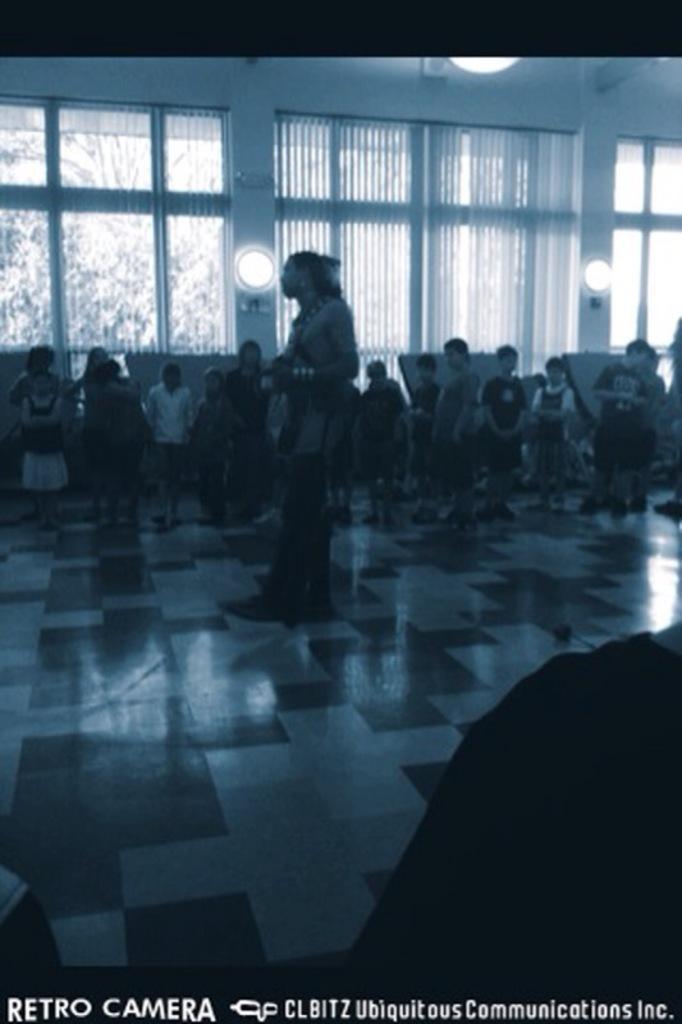Could you give a brief overview of what you see in this image? As we can see in the image there are white and black color tiles, few people here and there, window, curtains and lights. Outside the window there are trees. 